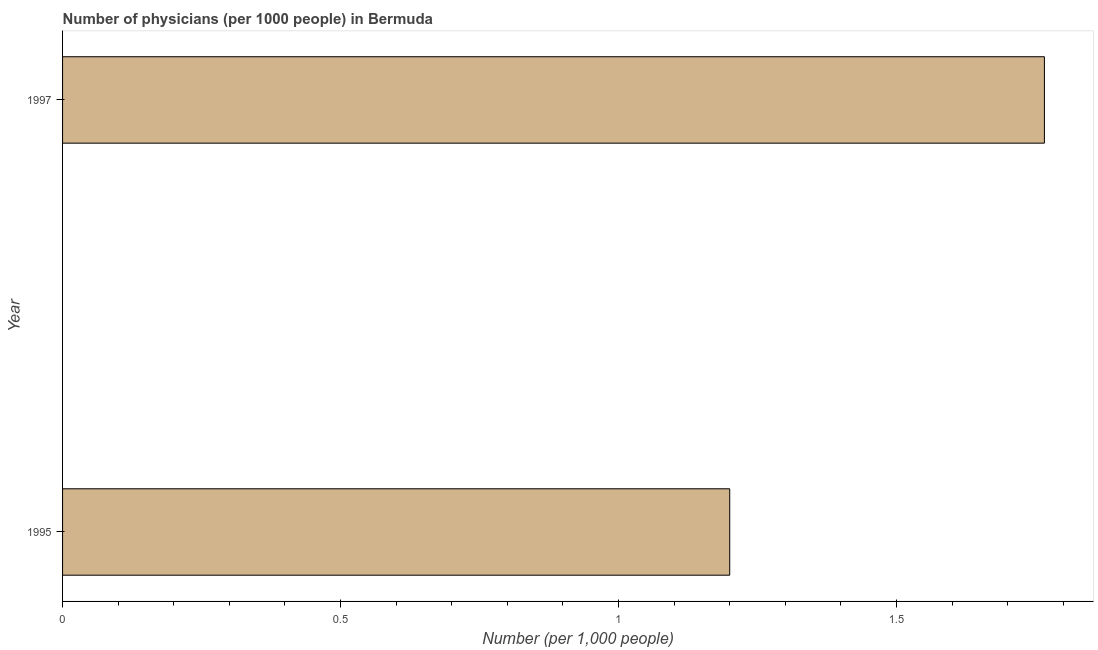Does the graph contain any zero values?
Your response must be concise. No. Does the graph contain grids?
Give a very brief answer. No. What is the title of the graph?
Provide a short and direct response. Number of physicians (per 1000 people) in Bermuda. What is the label or title of the X-axis?
Keep it short and to the point. Number (per 1,0 people). Across all years, what is the maximum number of physicians?
Your answer should be compact. 1.77. Across all years, what is the minimum number of physicians?
Offer a very short reply. 1.2. What is the sum of the number of physicians?
Offer a terse response. 2.97. What is the difference between the number of physicians in 1995 and 1997?
Offer a very short reply. -0.57. What is the average number of physicians per year?
Your answer should be very brief. 1.48. What is the median number of physicians?
Provide a short and direct response. 1.48. What is the ratio of the number of physicians in 1995 to that in 1997?
Your answer should be very brief. 0.68. Is the number of physicians in 1995 less than that in 1997?
Offer a very short reply. Yes. In how many years, is the number of physicians greater than the average number of physicians taken over all years?
Your response must be concise. 1. Are all the bars in the graph horizontal?
Make the answer very short. Yes. How many years are there in the graph?
Your answer should be compact. 2. What is the difference between two consecutive major ticks on the X-axis?
Your response must be concise. 0.5. Are the values on the major ticks of X-axis written in scientific E-notation?
Your answer should be compact. No. What is the Number (per 1,000 people) in 1997?
Keep it short and to the point. 1.77. What is the difference between the Number (per 1,000 people) in 1995 and 1997?
Provide a succinct answer. -0.57. What is the ratio of the Number (per 1,000 people) in 1995 to that in 1997?
Provide a short and direct response. 0.68. 